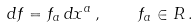<formula> <loc_0><loc_0><loc_500><loc_500>d f = f _ { a } \, d x ^ { a } \, , \quad f _ { a } \in R \, .</formula> 